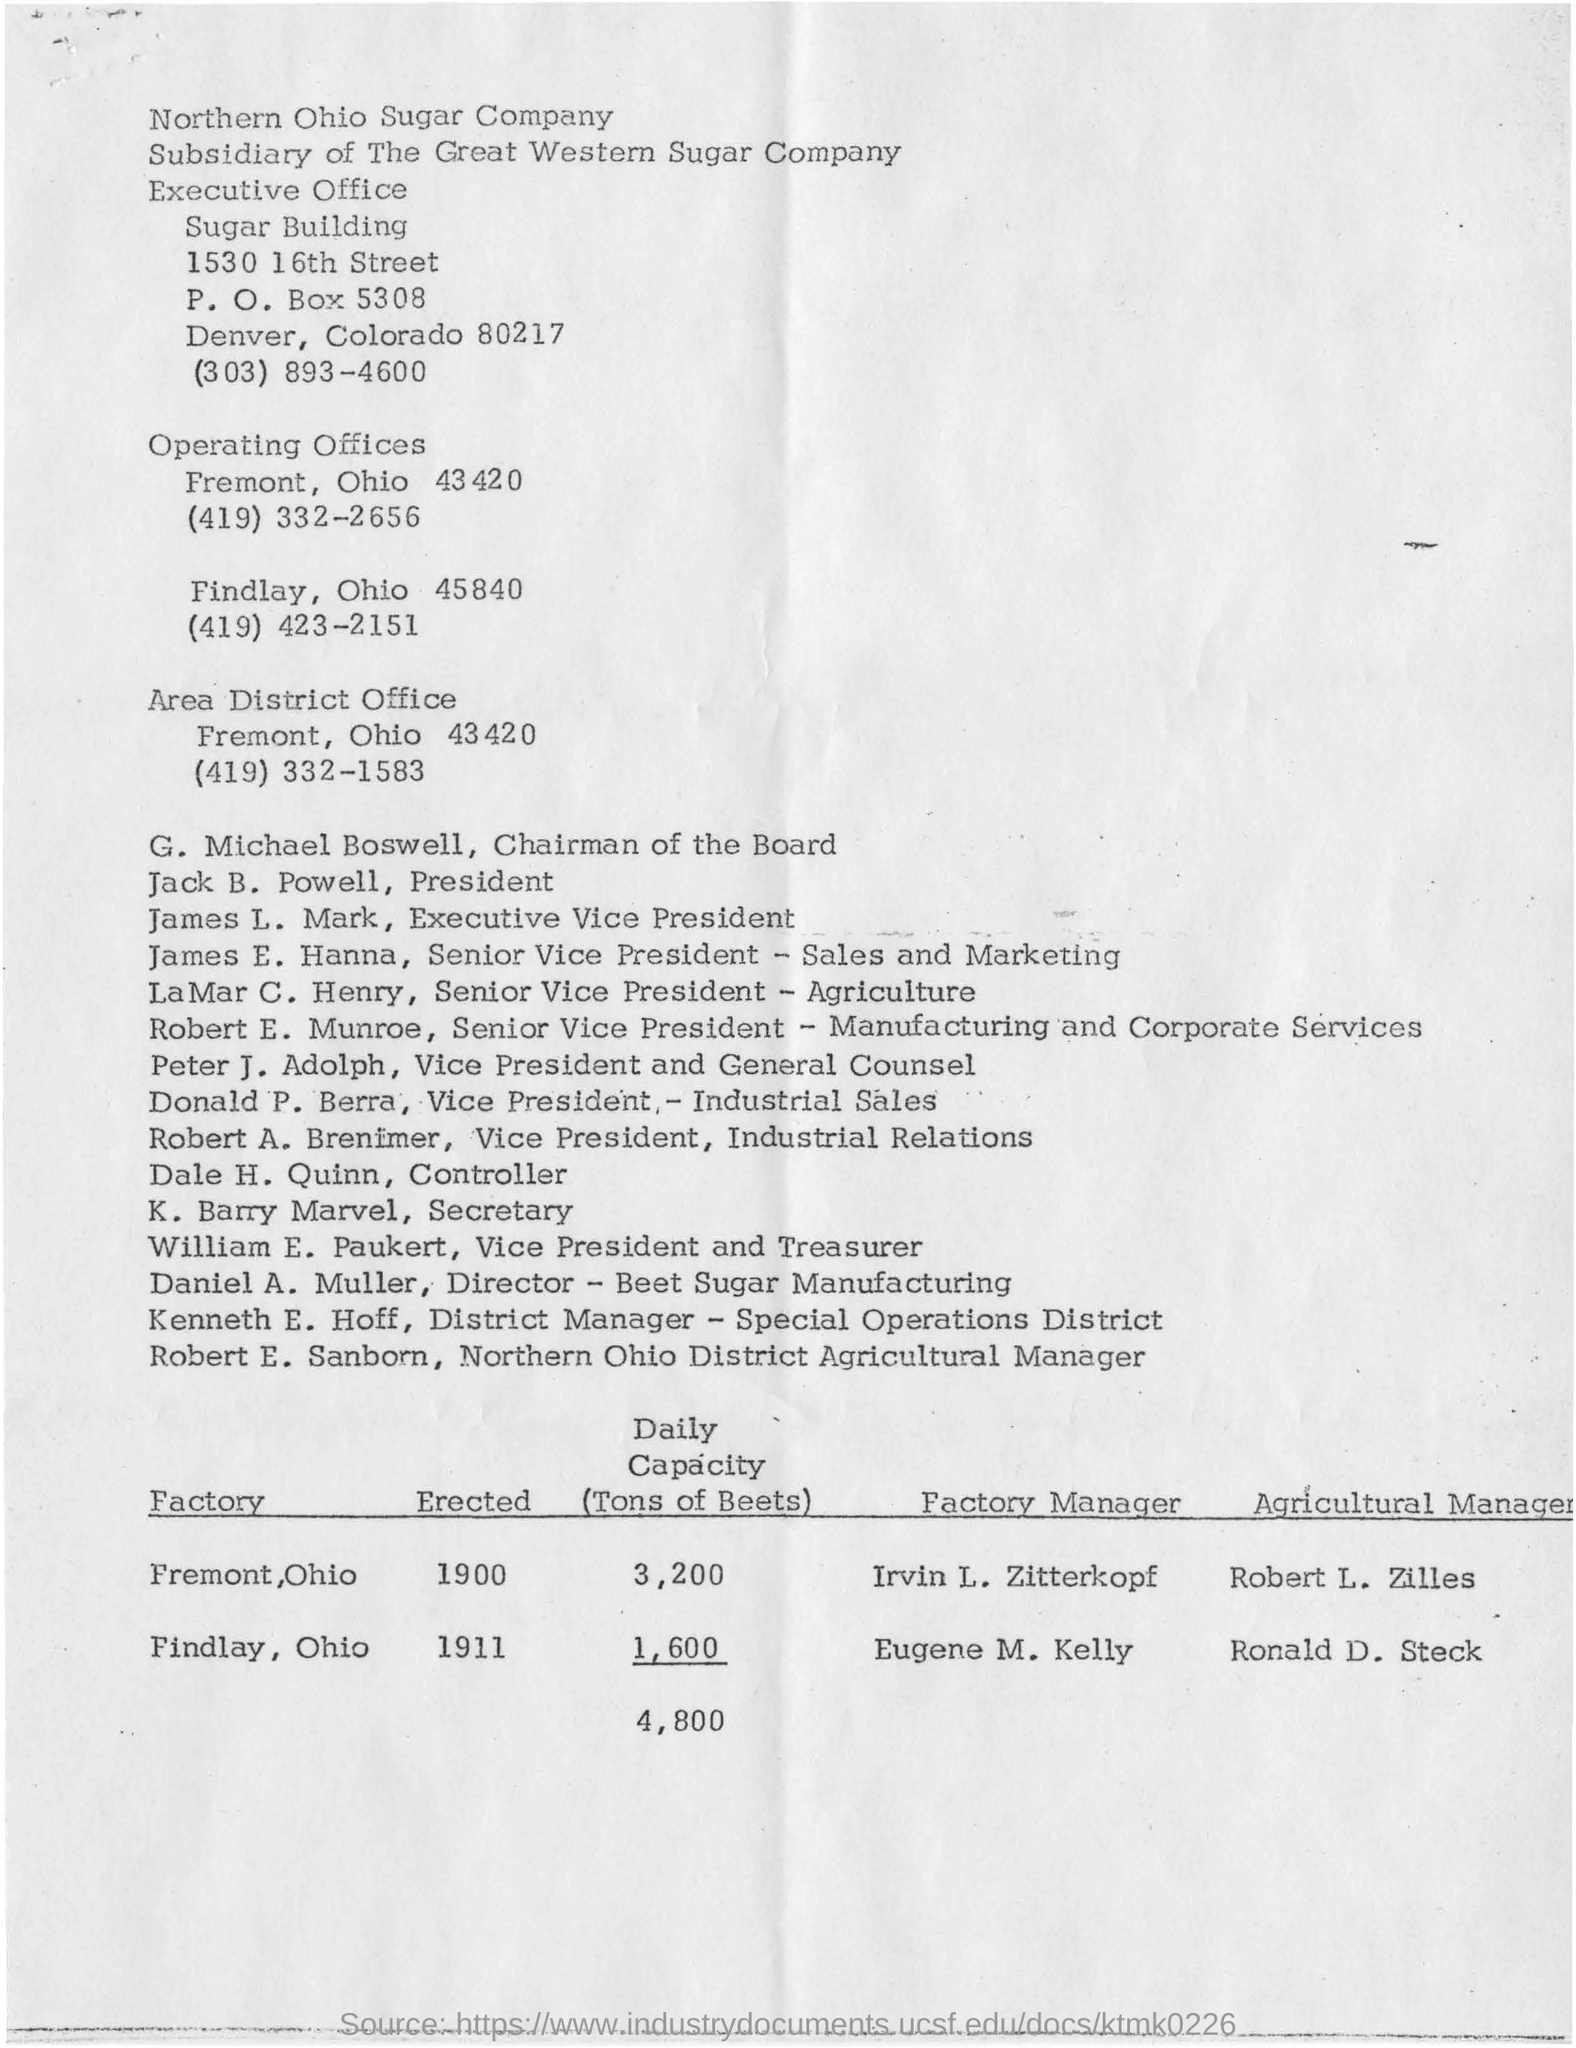what is the post box number for the location of 1530 16th street sugar building?
 5308 